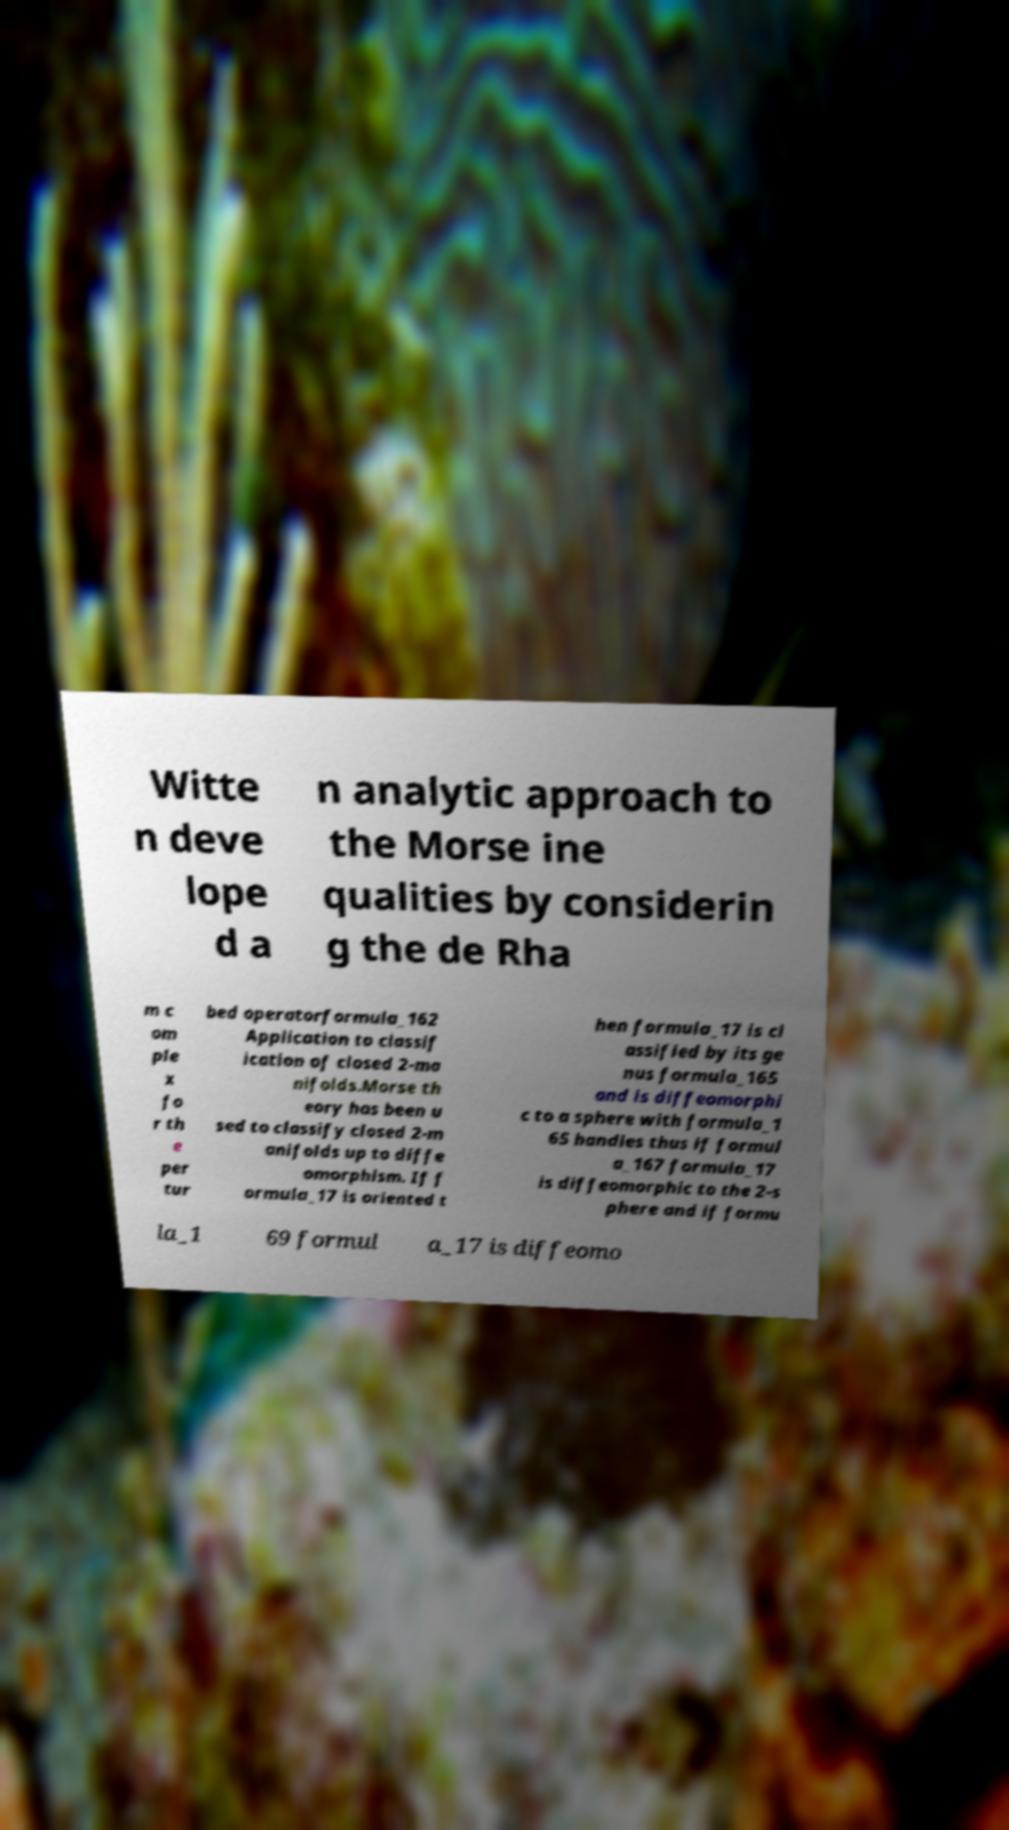There's text embedded in this image that I need extracted. Can you transcribe it verbatim? Witte n deve lope d a n analytic approach to the Morse ine qualities by considerin g the de Rha m c om ple x fo r th e per tur bed operatorformula_162 Application to classif ication of closed 2-ma nifolds.Morse th eory has been u sed to classify closed 2-m anifolds up to diffe omorphism. If f ormula_17 is oriented t hen formula_17 is cl assified by its ge nus formula_165 and is diffeomorphi c to a sphere with formula_1 65 handles thus if formul a_167 formula_17 is diffeomorphic to the 2-s phere and if formu la_1 69 formul a_17 is diffeomo 